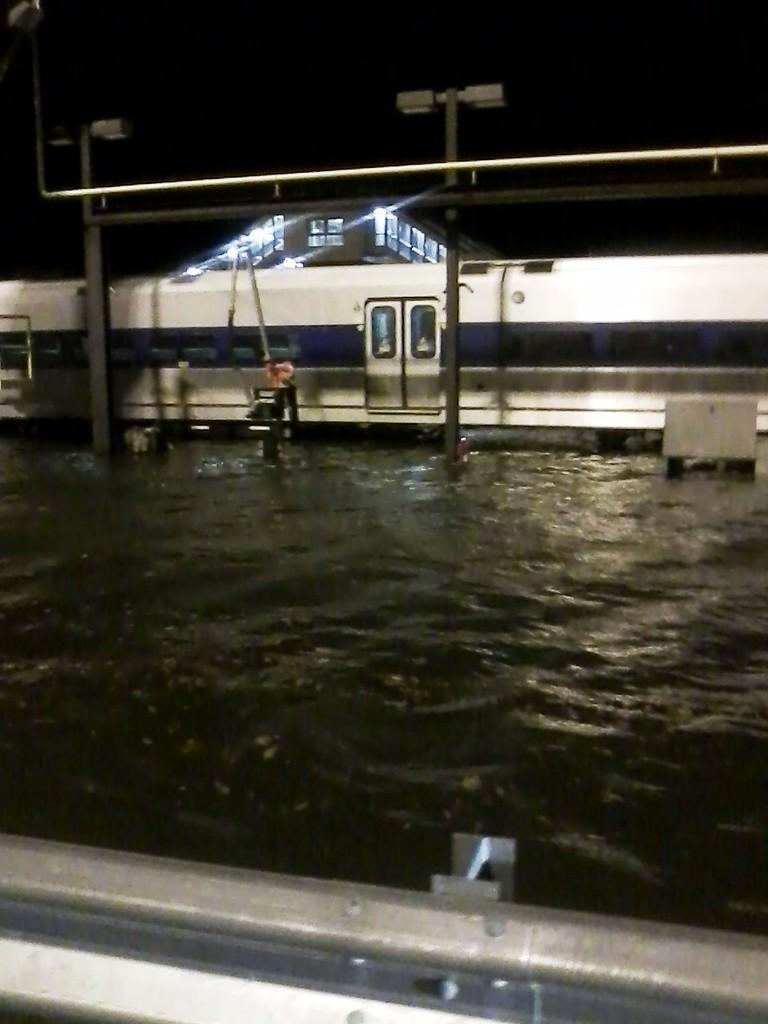Can you describe this image briefly? In this image we can see fence, water, train, light poles and a building in the background. 